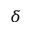<formula> <loc_0><loc_0><loc_500><loc_500>\delta</formula> 